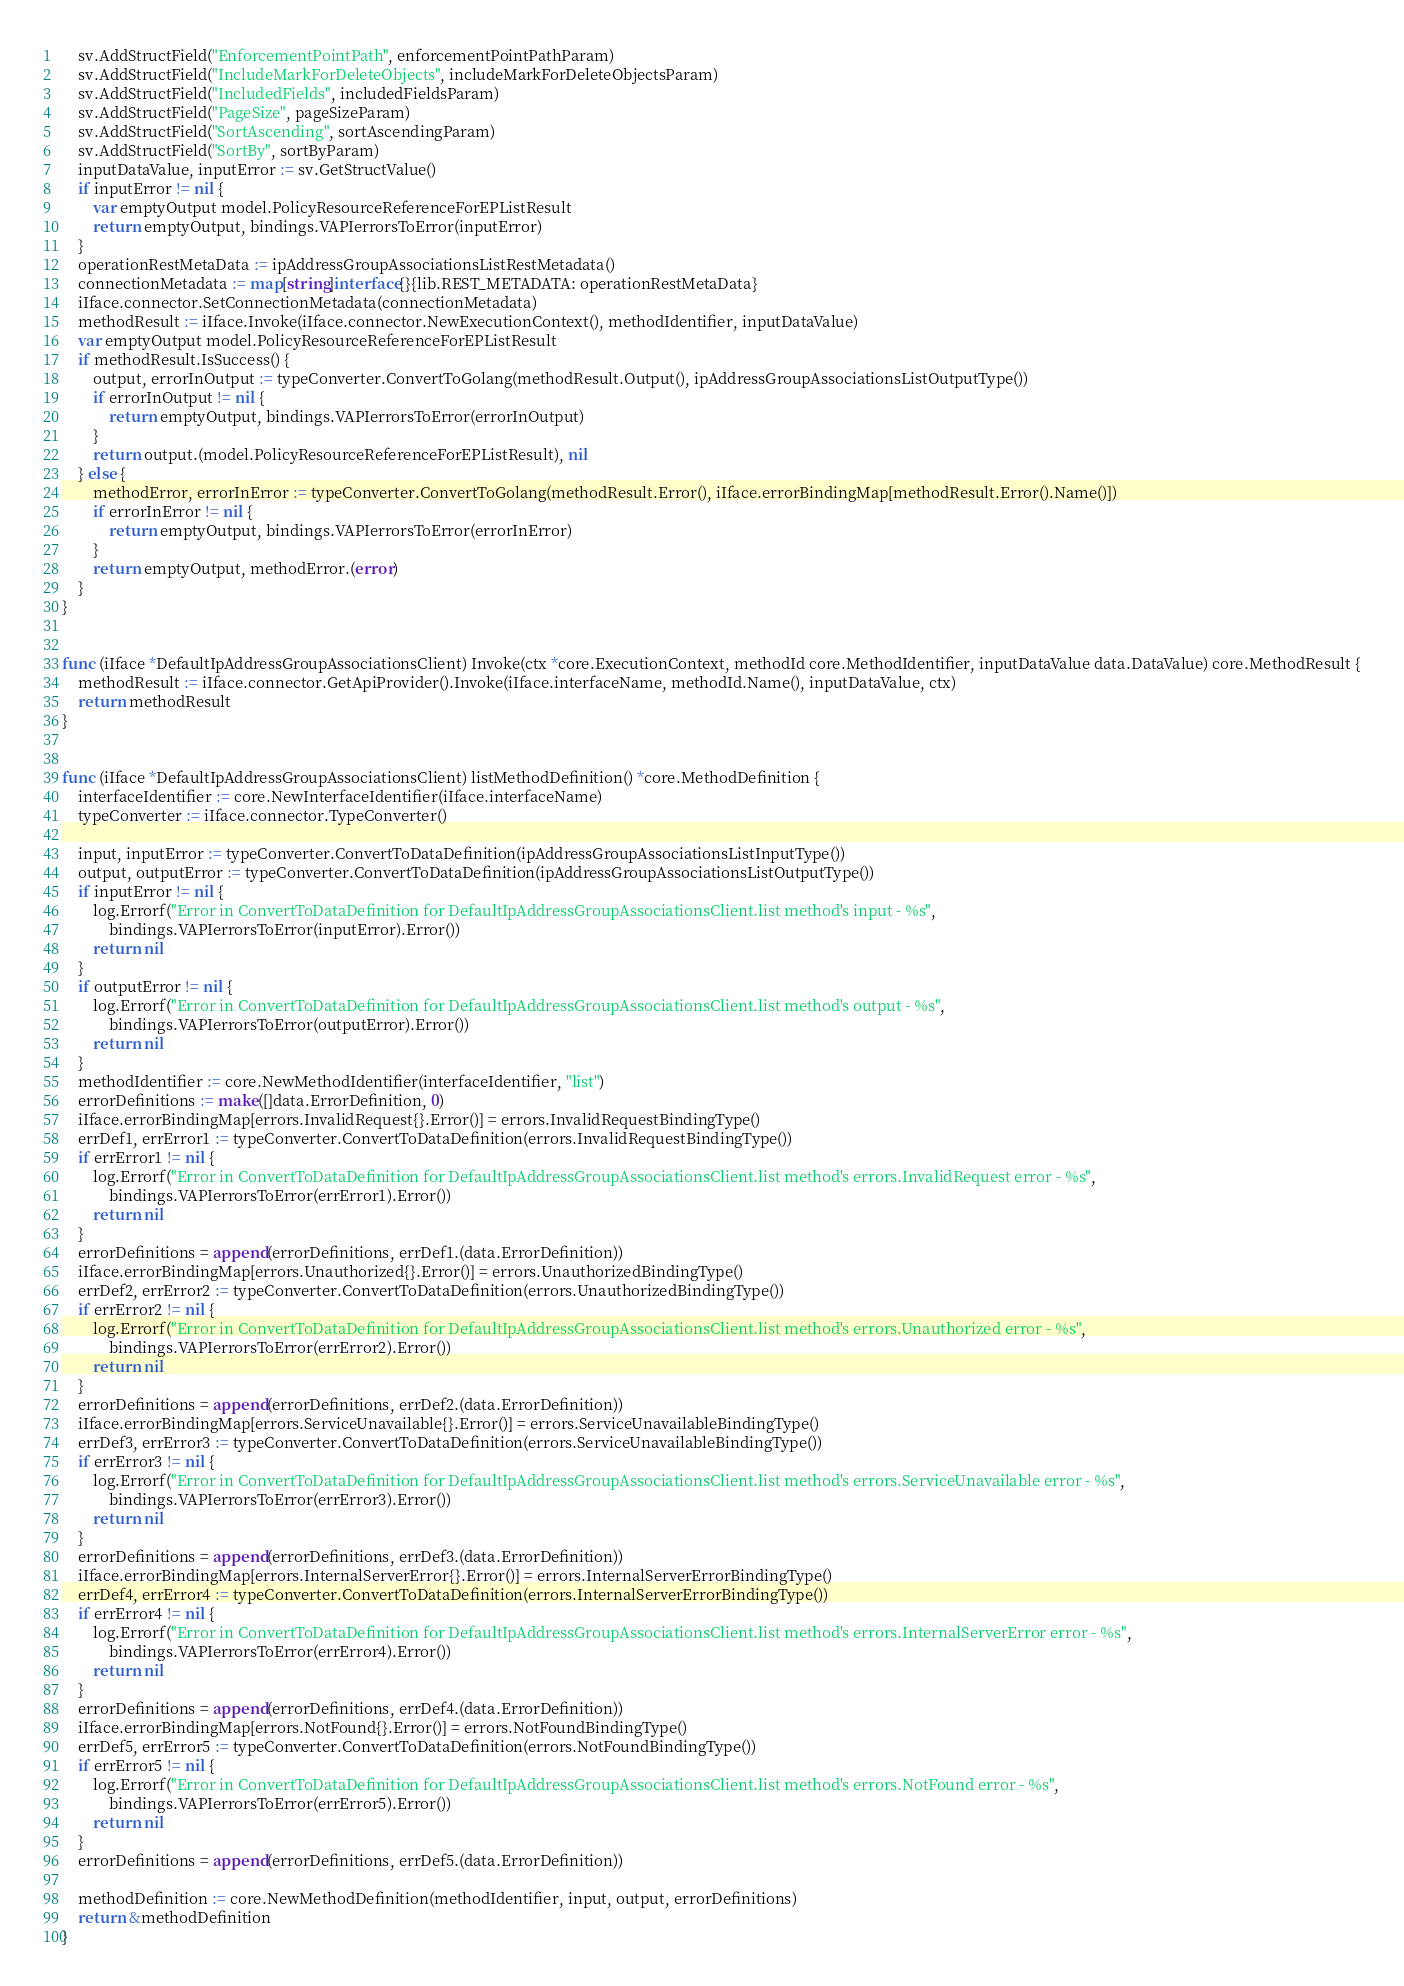<code> <loc_0><loc_0><loc_500><loc_500><_Go_>	sv.AddStructField("EnforcementPointPath", enforcementPointPathParam)
	sv.AddStructField("IncludeMarkForDeleteObjects", includeMarkForDeleteObjectsParam)
	sv.AddStructField("IncludedFields", includedFieldsParam)
	sv.AddStructField("PageSize", pageSizeParam)
	sv.AddStructField("SortAscending", sortAscendingParam)
	sv.AddStructField("SortBy", sortByParam)
	inputDataValue, inputError := sv.GetStructValue()
	if inputError != nil {
		var emptyOutput model.PolicyResourceReferenceForEPListResult
		return emptyOutput, bindings.VAPIerrorsToError(inputError)
	}
	operationRestMetaData := ipAddressGroupAssociationsListRestMetadata()
	connectionMetadata := map[string]interface{}{lib.REST_METADATA: operationRestMetaData}
	iIface.connector.SetConnectionMetadata(connectionMetadata)
	methodResult := iIface.Invoke(iIface.connector.NewExecutionContext(), methodIdentifier, inputDataValue)
	var emptyOutput model.PolicyResourceReferenceForEPListResult
	if methodResult.IsSuccess() {
		output, errorInOutput := typeConverter.ConvertToGolang(methodResult.Output(), ipAddressGroupAssociationsListOutputType())
		if errorInOutput != nil {
			return emptyOutput, bindings.VAPIerrorsToError(errorInOutput)
		}
		return output.(model.PolicyResourceReferenceForEPListResult), nil
	} else {
		methodError, errorInError := typeConverter.ConvertToGolang(methodResult.Error(), iIface.errorBindingMap[methodResult.Error().Name()])
		if errorInError != nil {
			return emptyOutput, bindings.VAPIerrorsToError(errorInError)
		}
		return emptyOutput, methodError.(error)
	}
}


func (iIface *DefaultIpAddressGroupAssociationsClient) Invoke(ctx *core.ExecutionContext, methodId core.MethodIdentifier, inputDataValue data.DataValue) core.MethodResult {
	methodResult := iIface.connector.GetApiProvider().Invoke(iIface.interfaceName, methodId.Name(), inputDataValue, ctx)
	return methodResult
}


func (iIface *DefaultIpAddressGroupAssociationsClient) listMethodDefinition() *core.MethodDefinition {
	interfaceIdentifier := core.NewInterfaceIdentifier(iIface.interfaceName)
	typeConverter := iIface.connector.TypeConverter()

	input, inputError := typeConverter.ConvertToDataDefinition(ipAddressGroupAssociationsListInputType())
	output, outputError := typeConverter.ConvertToDataDefinition(ipAddressGroupAssociationsListOutputType())
	if inputError != nil {
		log.Errorf("Error in ConvertToDataDefinition for DefaultIpAddressGroupAssociationsClient.list method's input - %s",
			bindings.VAPIerrorsToError(inputError).Error())
		return nil
	}
	if outputError != nil {
		log.Errorf("Error in ConvertToDataDefinition for DefaultIpAddressGroupAssociationsClient.list method's output - %s",
			bindings.VAPIerrorsToError(outputError).Error())
		return nil
	}
	methodIdentifier := core.NewMethodIdentifier(interfaceIdentifier, "list")
	errorDefinitions := make([]data.ErrorDefinition, 0)
	iIface.errorBindingMap[errors.InvalidRequest{}.Error()] = errors.InvalidRequestBindingType()
	errDef1, errError1 := typeConverter.ConvertToDataDefinition(errors.InvalidRequestBindingType())
	if errError1 != nil {
		log.Errorf("Error in ConvertToDataDefinition for DefaultIpAddressGroupAssociationsClient.list method's errors.InvalidRequest error - %s",
			bindings.VAPIerrorsToError(errError1).Error())
		return nil
	}
	errorDefinitions = append(errorDefinitions, errDef1.(data.ErrorDefinition))
	iIface.errorBindingMap[errors.Unauthorized{}.Error()] = errors.UnauthorizedBindingType()
	errDef2, errError2 := typeConverter.ConvertToDataDefinition(errors.UnauthorizedBindingType())
	if errError2 != nil {
		log.Errorf("Error in ConvertToDataDefinition for DefaultIpAddressGroupAssociationsClient.list method's errors.Unauthorized error - %s",
			bindings.VAPIerrorsToError(errError2).Error())
		return nil
	}
	errorDefinitions = append(errorDefinitions, errDef2.(data.ErrorDefinition))
	iIface.errorBindingMap[errors.ServiceUnavailable{}.Error()] = errors.ServiceUnavailableBindingType()
	errDef3, errError3 := typeConverter.ConvertToDataDefinition(errors.ServiceUnavailableBindingType())
	if errError3 != nil {
		log.Errorf("Error in ConvertToDataDefinition for DefaultIpAddressGroupAssociationsClient.list method's errors.ServiceUnavailable error - %s",
			bindings.VAPIerrorsToError(errError3).Error())
		return nil
	}
	errorDefinitions = append(errorDefinitions, errDef3.(data.ErrorDefinition))
	iIface.errorBindingMap[errors.InternalServerError{}.Error()] = errors.InternalServerErrorBindingType()
	errDef4, errError4 := typeConverter.ConvertToDataDefinition(errors.InternalServerErrorBindingType())
	if errError4 != nil {
		log.Errorf("Error in ConvertToDataDefinition for DefaultIpAddressGroupAssociationsClient.list method's errors.InternalServerError error - %s",
			bindings.VAPIerrorsToError(errError4).Error())
		return nil
	}
	errorDefinitions = append(errorDefinitions, errDef4.(data.ErrorDefinition))
	iIface.errorBindingMap[errors.NotFound{}.Error()] = errors.NotFoundBindingType()
	errDef5, errError5 := typeConverter.ConvertToDataDefinition(errors.NotFoundBindingType())
	if errError5 != nil {
		log.Errorf("Error in ConvertToDataDefinition for DefaultIpAddressGroupAssociationsClient.list method's errors.NotFound error - %s",
			bindings.VAPIerrorsToError(errError5).Error())
		return nil
	}
	errorDefinitions = append(errorDefinitions, errDef5.(data.ErrorDefinition))

	methodDefinition := core.NewMethodDefinition(methodIdentifier, input, output, errorDefinitions)
	return &methodDefinition
}
</code> 